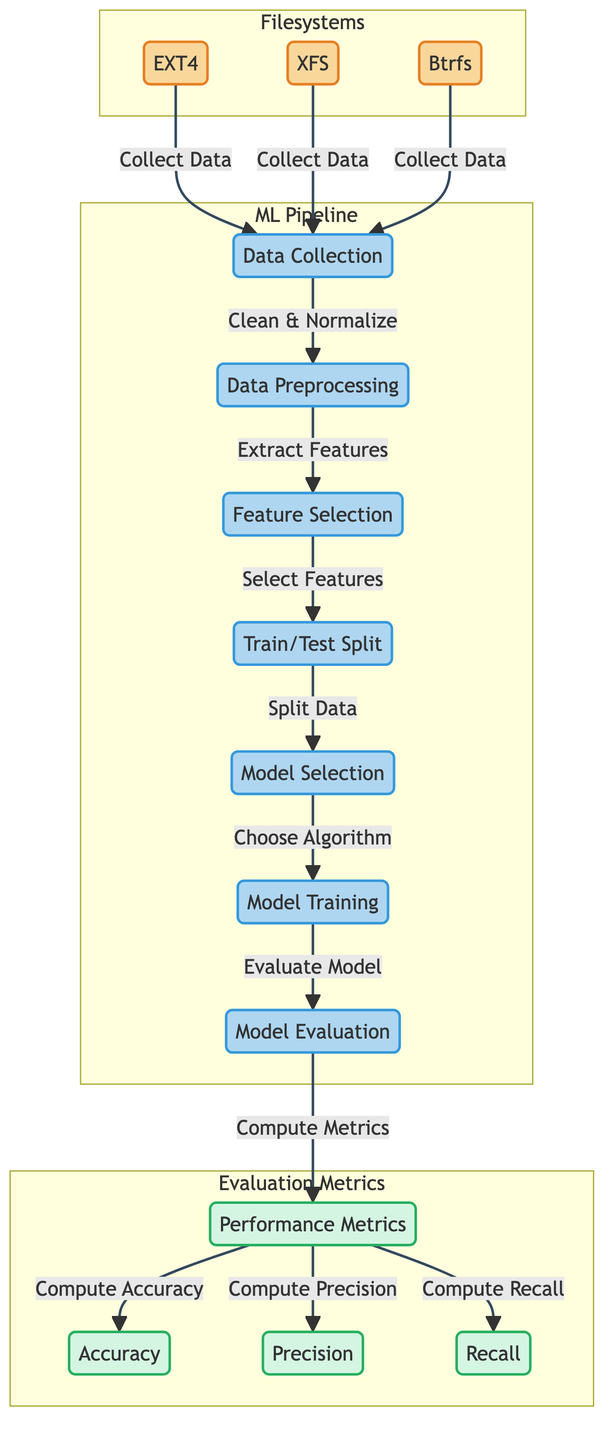What are the three types of filesystems included in the diagram? The diagram includes three filesystems: EXT4, XFS, and Btrfs, which are clearly labeled as part of the "Filesystems" subgraph.
Answer: EXT4, XFS, Btrfs What is the first step in the machine learning pipeline? The first step in the machine learning pipeline, as indicated in the "ML Pipeline" subgraph, is "Data Collection," with an arrow leading directly from the filesystem nodes to this process.
Answer: Data Collection How many performance metrics are computed in the evaluation process? The evaluation process in the diagram leads to three specific metrics: Accuracy, Precision, and Recall, as indicated in the "Evaluation Metrics" subgraph.
Answer: Three Which process comes after Feature Selection? According to the flow of the diagram, after "Feature Selection," the next process is "Train/Test Split," which is indicated by the arrow pointing from Feature Selection to Train/Test Split.
Answer: Train/Test Split What process is linked to Model Evaluation? In the diagram, "Evaluation" is the process directly linked to "Model Evaluation," as indicated by the arrow leading to the metrics calculation stage.
Answer: Evaluation Which filesystem type is the last in the data collection step? The diagram presents that the last filesystem node leading to "Data Collection" is Btrfs, as it is drawn last in a vertical alignment above this process.
Answer: Btrfs How many nodes are there in the ML Pipeline subgraph? The ML Pipeline subgraph includes six distinct nodes: Data Collection, Data Preprocessing, Feature Selection, Train/Test Split, Model Selection, and Training, which can be counted as individual elements.
Answer: Six Which metric is focused on the true positive rate? "Recall" is indicated in the diagram as one of the performance metrics, and it specifically represents the true positive rate in the context of model evaluation.
Answer: Recall 